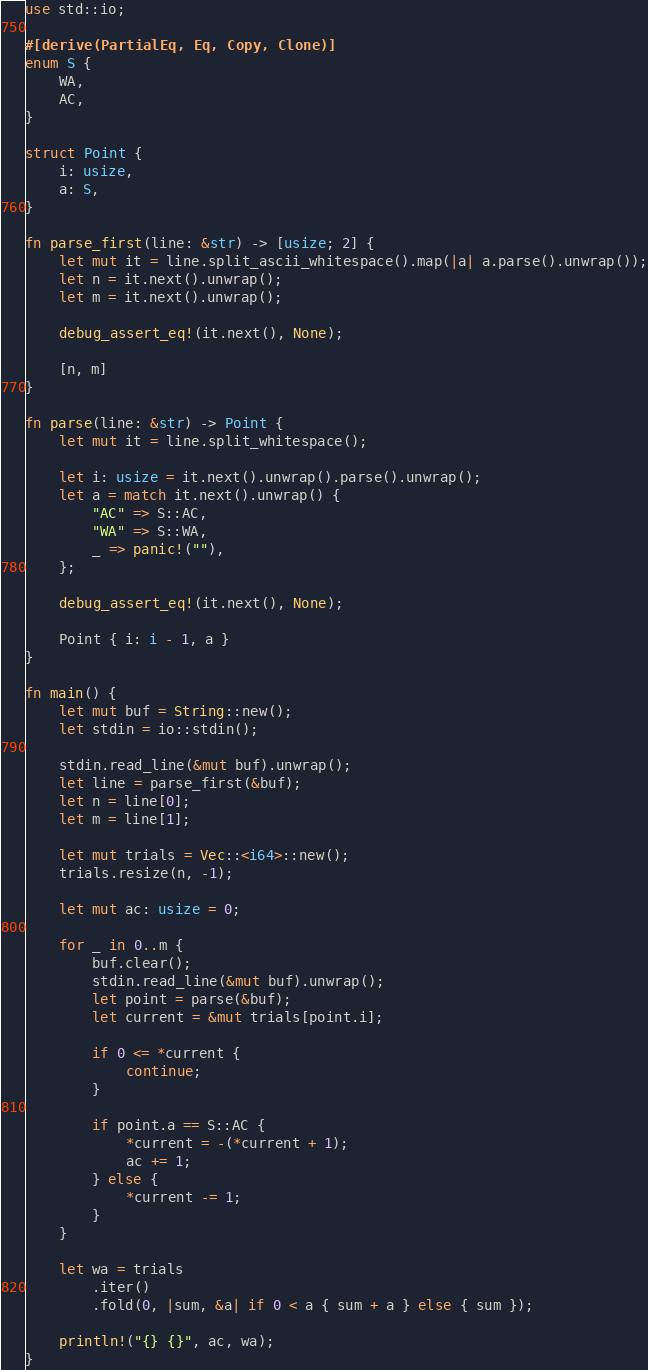<code> <loc_0><loc_0><loc_500><loc_500><_Rust_>use std::io;

#[derive(PartialEq, Eq, Copy, Clone)]
enum S {
    WA,
    AC,
}

struct Point {
    i: usize,
    a: S,
}

fn parse_first(line: &str) -> [usize; 2] {
    let mut it = line.split_ascii_whitespace().map(|a| a.parse().unwrap());
    let n = it.next().unwrap();
    let m = it.next().unwrap();

    debug_assert_eq!(it.next(), None);

    [n, m]
}

fn parse(line: &str) -> Point {
    let mut it = line.split_whitespace();

    let i: usize = it.next().unwrap().parse().unwrap();
    let a = match it.next().unwrap() {
        "AC" => S::AC,
        "WA" => S::WA,
        _ => panic!(""),
    };

    debug_assert_eq!(it.next(), None);

    Point { i: i - 1, a }
}

fn main() {
    let mut buf = String::new();
    let stdin = io::stdin();

    stdin.read_line(&mut buf).unwrap();
    let line = parse_first(&buf);
    let n = line[0];
    let m = line[1];

    let mut trials = Vec::<i64>::new();
    trials.resize(n, -1);

    let mut ac: usize = 0;

    for _ in 0..m {
        buf.clear();
        stdin.read_line(&mut buf).unwrap();
        let point = parse(&buf);
        let current = &mut trials[point.i];

        if 0 <= *current {
            continue;
        }

        if point.a == S::AC {
            *current = -(*current + 1);
            ac += 1;
        } else {
            *current -= 1;
        }
    }

    let wa = trials
        .iter()
        .fold(0, |sum, &a| if 0 < a { sum + a } else { sum });

    println!("{} {}", ac, wa);
}
</code> 